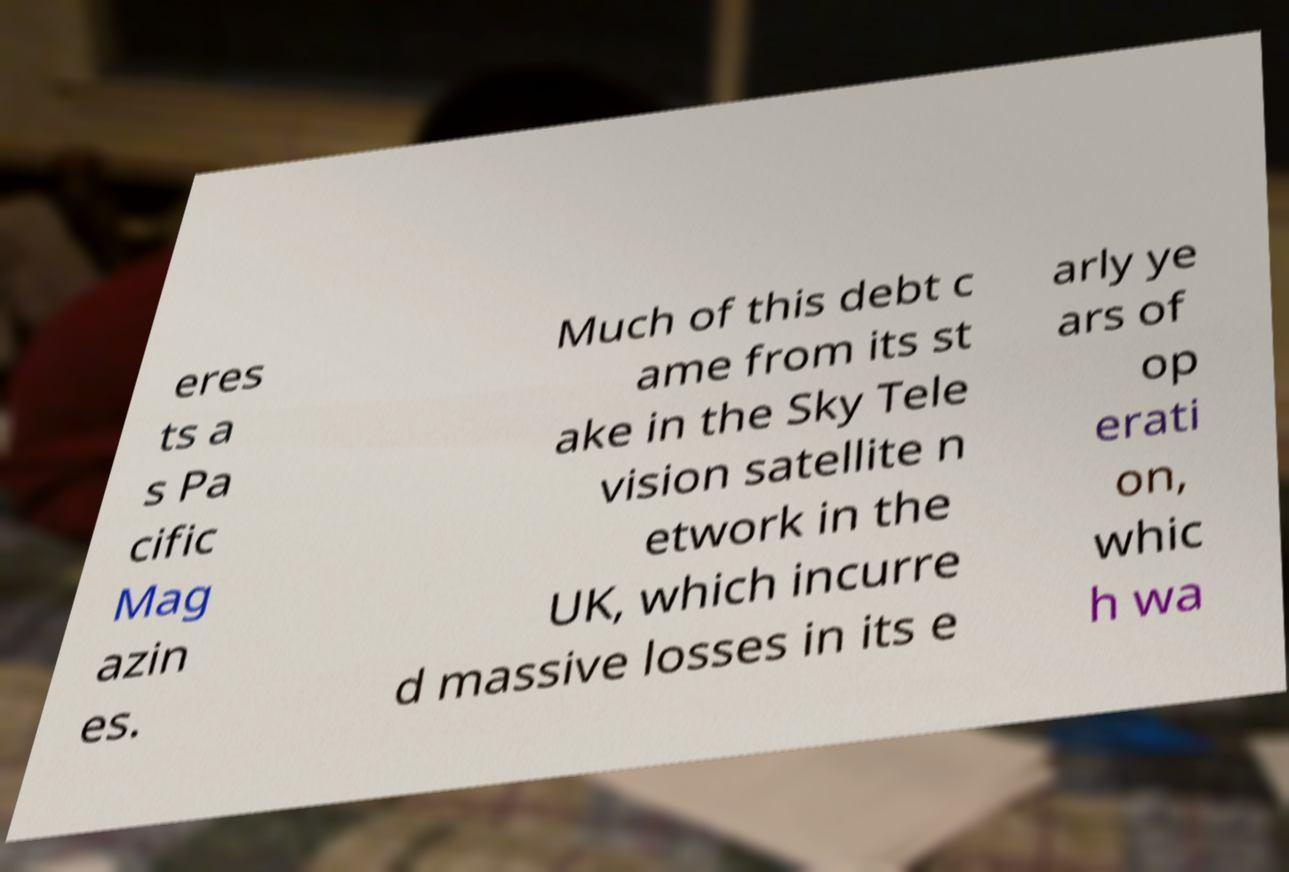Can you accurately transcribe the text from the provided image for me? eres ts a s Pa cific Mag azin es. Much of this debt c ame from its st ake in the Sky Tele vision satellite n etwork in the UK, which incurre d massive losses in its e arly ye ars of op erati on, whic h wa 